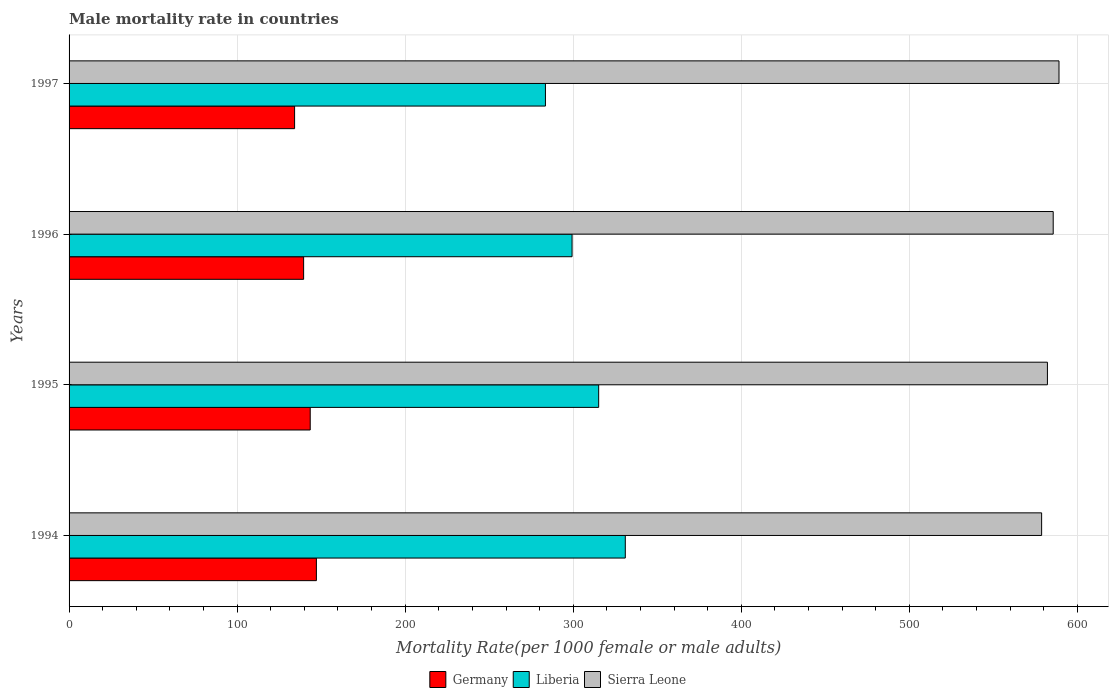How many groups of bars are there?
Make the answer very short. 4. How many bars are there on the 3rd tick from the top?
Offer a terse response. 3. How many bars are there on the 4th tick from the bottom?
Offer a very short reply. 3. What is the label of the 4th group of bars from the top?
Offer a very short reply. 1994. In how many cases, is the number of bars for a given year not equal to the number of legend labels?
Make the answer very short. 0. What is the male mortality rate in Sierra Leone in 1997?
Provide a succinct answer. 589.05. Across all years, what is the maximum male mortality rate in Germany?
Keep it short and to the point. 147.17. Across all years, what is the minimum male mortality rate in Germany?
Make the answer very short. 134.2. In which year was the male mortality rate in Sierra Leone maximum?
Offer a very short reply. 1997. In which year was the male mortality rate in Sierra Leone minimum?
Make the answer very short. 1994. What is the total male mortality rate in Germany in the graph?
Make the answer very short. 564.43. What is the difference between the male mortality rate in Germany in 1996 and that in 1997?
Provide a succinct answer. 5.38. What is the difference between the male mortality rate in Sierra Leone in 1996 and the male mortality rate in Germany in 1995?
Your response must be concise. 442.11. What is the average male mortality rate in Germany per year?
Provide a succinct answer. 141.11. In the year 1996, what is the difference between the male mortality rate in Sierra Leone and male mortality rate in Liberia?
Your answer should be very brief. 286.31. What is the ratio of the male mortality rate in Germany in 1994 to that in 1996?
Your answer should be very brief. 1.05. Is the difference between the male mortality rate in Sierra Leone in 1996 and 1997 greater than the difference between the male mortality rate in Liberia in 1996 and 1997?
Make the answer very short. No. What is the difference between the highest and the second highest male mortality rate in Sierra Leone?
Your answer should be very brief. 3.45. What is the difference between the highest and the lowest male mortality rate in Liberia?
Provide a short and direct response. 47.52. What does the 1st bar from the top in 1994 represents?
Provide a short and direct response. Sierra Leone. What does the 1st bar from the bottom in 1997 represents?
Offer a terse response. Germany. What is the difference between two consecutive major ticks on the X-axis?
Make the answer very short. 100. Does the graph contain grids?
Keep it short and to the point. Yes. What is the title of the graph?
Offer a terse response. Male mortality rate in countries. Does "New Zealand" appear as one of the legend labels in the graph?
Your answer should be compact. No. What is the label or title of the X-axis?
Offer a very short reply. Mortality Rate(per 1000 female or male adults). What is the label or title of the Y-axis?
Your response must be concise. Years. What is the Mortality Rate(per 1000 female or male adults) of Germany in 1994?
Your answer should be very brief. 147.17. What is the Mortality Rate(per 1000 female or male adults) in Liberia in 1994?
Provide a short and direct response. 330.98. What is the Mortality Rate(per 1000 female or male adults) of Sierra Leone in 1994?
Your response must be concise. 578.72. What is the Mortality Rate(per 1000 female or male adults) in Germany in 1995?
Your answer should be very brief. 143.49. What is the Mortality Rate(per 1000 female or male adults) in Liberia in 1995?
Keep it short and to the point. 315.14. What is the Mortality Rate(per 1000 female or male adults) in Sierra Leone in 1995?
Ensure brevity in your answer.  582.16. What is the Mortality Rate(per 1000 female or male adults) in Germany in 1996?
Provide a succinct answer. 139.57. What is the Mortality Rate(per 1000 female or male adults) in Liberia in 1996?
Your answer should be compact. 299.3. What is the Mortality Rate(per 1000 female or male adults) of Sierra Leone in 1996?
Offer a terse response. 585.61. What is the Mortality Rate(per 1000 female or male adults) of Germany in 1997?
Provide a succinct answer. 134.2. What is the Mortality Rate(per 1000 female or male adults) in Liberia in 1997?
Provide a short and direct response. 283.46. What is the Mortality Rate(per 1000 female or male adults) in Sierra Leone in 1997?
Offer a very short reply. 589.05. Across all years, what is the maximum Mortality Rate(per 1000 female or male adults) in Germany?
Ensure brevity in your answer.  147.17. Across all years, what is the maximum Mortality Rate(per 1000 female or male adults) of Liberia?
Keep it short and to the point. 330.98. Across all years, what is the maximum Mortality Rate(per 1000 female or male adults) in Sierra Leone?
Offer a very short reply. 589.05. Across all years, what is the minimum Mortality Rate(per 1000 female or male adults) in Germany?
Ensure brevity in your answer.  134.2. Across all years, what is the minimum Mortality Rate(per 1000 female or male adults) of Liberia?
Offer a very short reply. 283.46. Across all years, what is the minimum Mortality Rate(per 1000 female or male adults) in Sierra Leone?
Make the answer very short. 578.72. What is the total Mortality Rate(per 1000 female or male adults) of Germany in the graph?
Offer a very short reply. 564.43. What is the total Mortality Rate(per 1000 female or male adults) of Liberia in the graph?
Offer a terse response. 1228.88. What is the total Mortality Rate(per 1000 female or male adults) of Sierra Leone in the graph?
Give a very brief answer. 2335.54. What is the difference between the Mortality Rate(per 1000 female or male adults) in Germany in 1994 and that in 1995?
Ensure brevity in your answer.  3.68. What is the difference between the Mortality Rate(per 1000 female or male adults) in Liberia in 1994 and that in 1995?
Give a very brief answer. 15.84. What is the difference between the Mortality Rate(per 1000 female or male adults) in Sierra Leone in 1994 and that in 1995?
Your response must be concise. -3.44. What is the difference between the Mortality Rate(per 1000 female or male adults) of Germany in 1994 and that in 1996?
Keep it short and to the point. 7.6. What is the difference between the Mortality Rate(per 1000 female or male adults) of Liberia in 1994 and that in 1996?
Provide a short and direct response. 31.68. What is the difference between the Mortality Rate(per 1000 female or male adults) of Sierra Leone in 1994 and that in 1996?
Ensure brevity in your answer.  -6.89. What is the difference between the Mortality Rate(per 1000 female or male adults) of Germany in 1994 and that in 1997?
Your answer should be very brief. 12.97. What is the difference between the Mortality Rate(per 1000 female or male adults) in Liberia in 1994 and that in 1997?
Make the answer very short. 47.52. What is the difference between the Mortality Rate(per 1000 female or male adults) of Sierra Leone in 1994 and that in 1997?
Give a very brief answer. -10.34. What is the difference between the Mortality Rate(per 1000 female or male adults) of Germany in 1995 and that in 1996?
Provide a succinct answer. 3.92. What is the difference between the Mortality Rate(per 1000 female or male adults) in Liberia in 1995 and that in 1996?
Your response must be concise. 15.84. What is the difference between the Mortality Rate(per 1000 female or male adults) of Sierra Leone in 1995 and that in 1996?
Ensure brevity in your answer.  -3.44. What is the difference between the Mortality Rate(per 1000 female or male adults) in Germany in 1995 and that in 1997?
Offer a terse response. 9.3. What is the difference between the Mortality Rate(per 1000 female or male adults) in Liberia in 1995 and that in 1997?
Provide a short and direct response. 31.68. What is the difference between the Mortality Rate(per 1000 female or male adults) in Sierra Leone in 1995 and that in 1997?
Provide a short and direct response. -6.89. What is the difference between the Mortality Rate(per 1000 female or male adults) in Germany in 1996 and that in 1997?
Provide a succinct answer. 5.38. What is the difference between the Mortality Rate(per 1000 female or male adults) in Liberia in 1996 and that in 1997?
Your response must be concise. 15.84. What is the difference between the Mortality Rate(per 1000 female or male adults) of Sierra Leone in 1996 and that in 1997?
Keep it short and to the point. -3.44. What is the difference between the Mortality Rate(per 1000 female or male adults) in Germany in 1994 and the Mortality Rate(per 1000 female or male adults) in Liberia in 1995?
Keep it short and to the point. -167.97. What is the difference between the Mortality Rate(per 1000 female or male adults) in Germany in 1994 and the Mortality Rate(per 1000 female or male adults) in Sierra Leone in 1995?
Provide a succinct answer. -434.99. What is the difference between the Mortality Rate(per 1000 female or male adults) of Liberia in 1994 and the Mortality Rate(per 1000 female or male adults) of Sierra Leone in 1995?
Your answer should be compact. -251.18. What is the difference between the Mortality Rate(per 1000 female or male adults) in Germany in 1994 and the Mortality Rate(per 1000 female or male adults) in Liberia in 1996?
Your answer should be compact. -152.13. What is the difference between the Mortality Rate(per 1000 female or male adults) of Germany in 1994 and the Mortality Rate(per 1000 female or male adults) of Sierra Leone in 1996?
Offer a very short reply. -438.44. What is the difference between the Mortality Rate(per 1000 female or male adults) in Liberia in 1994 and the Mortality Rate(per 1000 female or male adults) in Sierra Leone in 1996?
Give a very brief answer. -254.63. What is the difference between the Mortality Rate(per 1000 female or male adults) in Germany in 1994 and the Mortality Rate(per 1000 female or male adults) in Liberia in 1997?
Give a very brief answer. -136.29. What is the difference between the Mortality Rate(per 1000 female or male adults) in Germany in 1994 and the Mortality Rate(per 1000 female or male adults) in Sierra Leone in 1997?
Offer a terse response. -441.88. What is the difference between the Mortality Rate(per 1000 female or male adults) of Liberia in 1994 and the Mortality Rate(per 1000 female or male adults) of Sierra Leone in 1997?
Your answer should be compact. -258.07. What is the difference between the Mortality Rate(per 1000 female or male adults) of Germany in 1995 and the Mortality Rate(per 1000 female or male adults) of Liberia in 1996?
Offer a very short reply. -155.81. What is the difference between the Mortality Rate(per 1000 female or male adults) of Germany in 1995 and the Mortality Rate(per 1000 female or male adults) of Sierra Leone in 1996?
Provide a succinct answer. -442.11. What is the difference between the Mortality Rate(per 1000 female or male adults) in Liberia in 1995 and the Mortality Rate(per 1000 female or male adults) in Sierra Leone in 1996?
Ensure brevity in your answer.  -270.47. What is the difference between the Mortality Rate(per 1000 female or male adults) in Germany in 1995 and the Mortality Rate(per 1000 female or male adults) in Liberia in 1997?
Provide a short and direct response. -139.97. What is the difference between the Mortality Rate(per 1000 female or male adults) of Germany in 1995 and the Mortality Rate(per 1000 female or male adults) of Sierra Leone in 1997?
Ensure brevity in your answer.  -445.56. What is the difference between the Mortality Rate(per 1000 female or male adults) of Liberia in 1995 and the Mortality Rate(per 1000 female or male adults) of Sierra Leone in 1997?
Provide a short and direct response. -273.91. What is the difference between the Mortality Rate(per 1000 female or male adults) in Germany in 1996 and the Mortality Rate(per 1000 female or male adults) in Liberia in 1997?
Offer a terse response. -143.89. What is the difference between the Mortality Rate(per 1000 female or male adults) in Germany in 1996 and the Mortality Rate(per 1000 female or male adults) in Sierra Leone in 1997?
Give a very brief answer. -449.48. What is the difference between the Mortality Rate(per 1000 female or male adults) in Liberia in 1996 and the Mortality Rate(per 1000 female or male adults) in Sierra Leone in 1997?
Make the answer very short. -289.75. What is the average Mortality Rate(per 1000 female or male adults) of Germany per year?
Your answer should be compact. 141.11. What is the average Mortality Rate(per 1000 female or male adults) in Liberia per year?
Keep it short and to the point. 307.22. What is the average Mortality Rate(per 1000 female or male adults) of Sierra Leone per year?
Provide a short and direct response. 583.88. In the year 1994, what is the difference between the Mortality Rate(per 1000 female or male adults) of Germany and Mortality Rate(per 1000 female or male adults) of Liberia?
Give a very brief answer. -183.81. In the year 1994, what is the difference between the Mortality Rate(per 1000 female or male adults) in Germany and Mortality Rate(per 1000 female or male adults) in Sierra Leone?
Provide a short and direct response. -431.55. In the year 1994, what is the difference between the Mortality Rate(per 1000 female or male adults) of Liberia and Mortality Rate(per 1000 female or male adults) of Sierra Leone?
Provide a short and direct response. -247.74. In the year 1995, what is the difference between the Mortality Rate(per 1000 female or male adults) in Germany and Mortality Rate(per 1000 female or male adults) in Liberia?
Provide a short and direct response. -171.65. In the year 1995, what is the difference between the Mortality Rate(per 1000 female or male adults) in Germany and Mortality Rate(per 1000 female or male adults) in Sierra Leone?
Provide a short and direct response. -438.67. In the year 1995, what is the difference between the Mortality Rate(per 1000 female or male adults) of Liberia and Mortality Rate(per 1000 female or male adults) of Sierra Leone?
Offer a very short reply. -267.02. In the year 1996, what is the difference between the Mortality Rate(per 1000 female or male adults) in Germany and Mortality Rate(per 1000 female or male adults) in Liberia?
Your answer should be compact. -159.73. In the year 1996, what is the difference between the Mortality Rate(per 1000 female or male adults) in Germany and Mortality Rate(per 1000 female or male adults) in Sierra Leone?
Provide a succinct answer. -446.03. In the year 1996, what is the difference between the Mortality Rate(per 1000 female or male adults) in Liberia and Mortality Rate(per 1000 female or male adults) in Sierra Leone?
Offer a terse response. -286.31. In the year 1997, what is the difference between the Mortality Rate(per 1000 female or male adults) of Germany and Mortality Rate(per 1000 female or male adults) of Liberia?
Make the answer very short. -149.27. In the year 1997, what is the difference between the Mortality Rate(per 1000 female or male adults) of Germany and Mortality Rate(per 1000 female or male adults) of Sierra Leone?
Offer a very short reply. -454.86. In the year 1997, what is the difference between the Mortality Rate(per 1000 female or male adults) in Liberia and Mortality Rate(per 1000 female or male adults) in Sierra Leone?
Your answer should be very brief. -305.59. What is the ratio of the Mortality Rate(per 1000 female or male adults) of Germany in 1994 to that in 1995?
Give a very brief answer. 1.03. What is the ratio of the Mortality Rate(per 1000 female or male adults) of Liberia in 1994 to that in 1995?
Ensure brevity in your answer.  1.05. What is the ratio of the Mortality Rate(per 1000 female or male adults) of Sierra Leone in 1994 to that in 1995?
Your answer should be very brief. 0.99. What is the ratio of the Mortality Rate(per 1000 female or male adults) in Germany in 1994 to that in 1996?
Offer a terse response. 1.05. What is the ratio of the Mortality Rate(per 1000 female or male adults) of Liberia in 1994 to that in 1996?
Your answer should be compact. 1.11. What is the ratio of the Mortality Rate(per 1000 female or male adults) in Sierra Leone in 1994 to that in 1996?
Your response must be concise. 0.99. What is the ratio of the Mortality Rate(per 1000 female or male adults) in Germany in 1994 to that in 1997?
Offer a very short reply. 1.1. What is the ratio of the Mortality Rate(per 1000 female or male adults) of Liberia in 1994 to that in 1997?
Give a very brief answer. 1.17. What is the ratio of the Mortality Rate(per 1000 female or male adults) of Sierra Leone in 1994 to that in 1997?
Offer a terse response. 0.98. What is the ratio of the Mortality Rate(per 1000 female or male adults) of Germany in 1995 to that in 1996?
Your answer should be very brief. 1.03. What is the ratio of the Mortality Rate(per 1000 female or male adults) of Liberia in 1995 to that in 1996?
Keep it short and to the point. 1.05. What is the ratio of the Mortality Rate(per 1000 female or male adults) in Sierra Leone in 1995 to that in 1996?
Your answer should be very brief. 0.99. What is the ratio of the Mortality Rate(per 1000 female or male adults) of Germany in 1995 to that in 1997?
Ensure brevity in your answer.  1.07. What is the ratio of the Mortality Rate(per 1000 female or male adults) of Liberia in 1995 to that in 1997?
Provide a short and direct response. 1.11. What is the ratio of the Mortality Rate(per 1000 female or male adults) in Sierra Leone in 1995 to that in 1997?
Your answer should be compact. 0.99. What is the ratio of the Mortality Rate(per 1000 female or male adults) in Germany in 1996 to that in 1997?
Make the answer very short. 1.04. What is the ratio of the Mortality Rate(per 1000 female or male adults) in Liberia in 1996 to that in 1997?
Provide a short and direct response. 1.06. What is the ratio of the Mortality Rate(per 1000 female or male adults) in Sierra Leone in 1996 to that in 1997?
Your answer should be very brief. 0.99. What is the difference between the highest and the second highest Mortality Rate(per 1000 female or male adults) of Germany?
Make the answer very short. 3.68. What is the difference between the highest and the second highest Mortality Rate(per 1000 female or male adults) of Liberia?
Your answer should be very brief. 15.84. What is the difference between the highest and the second highest Mortality Rate(per 1000 female or male adults) in Sierra Leone?
Provide a succinct answer. 3.44. What is the difference between the highest and the lowest Mortality Rate(per 1000 female or male adults) in Germany?
Offer a very short reply. 12.97. What is the difference between the highest and the lowest Mortality Rate(per 1000 female or male adults) in Liberia?
Provide a succinct answer. 47.52. What is the difference between the highest and the lowest Mortality Rate(per 1000 female or male adults) of Sierra Leone?
Keep it short and to the point. 10.34. 